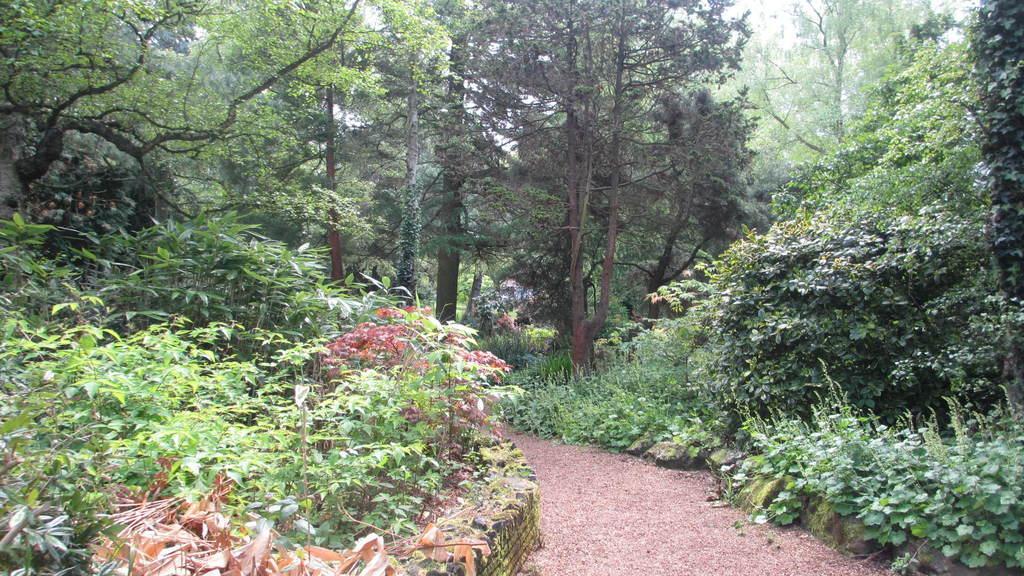Please provide a concise description of this image. In this picture there is a way at the bottom side of the image and there is greenery around the area of the image. 